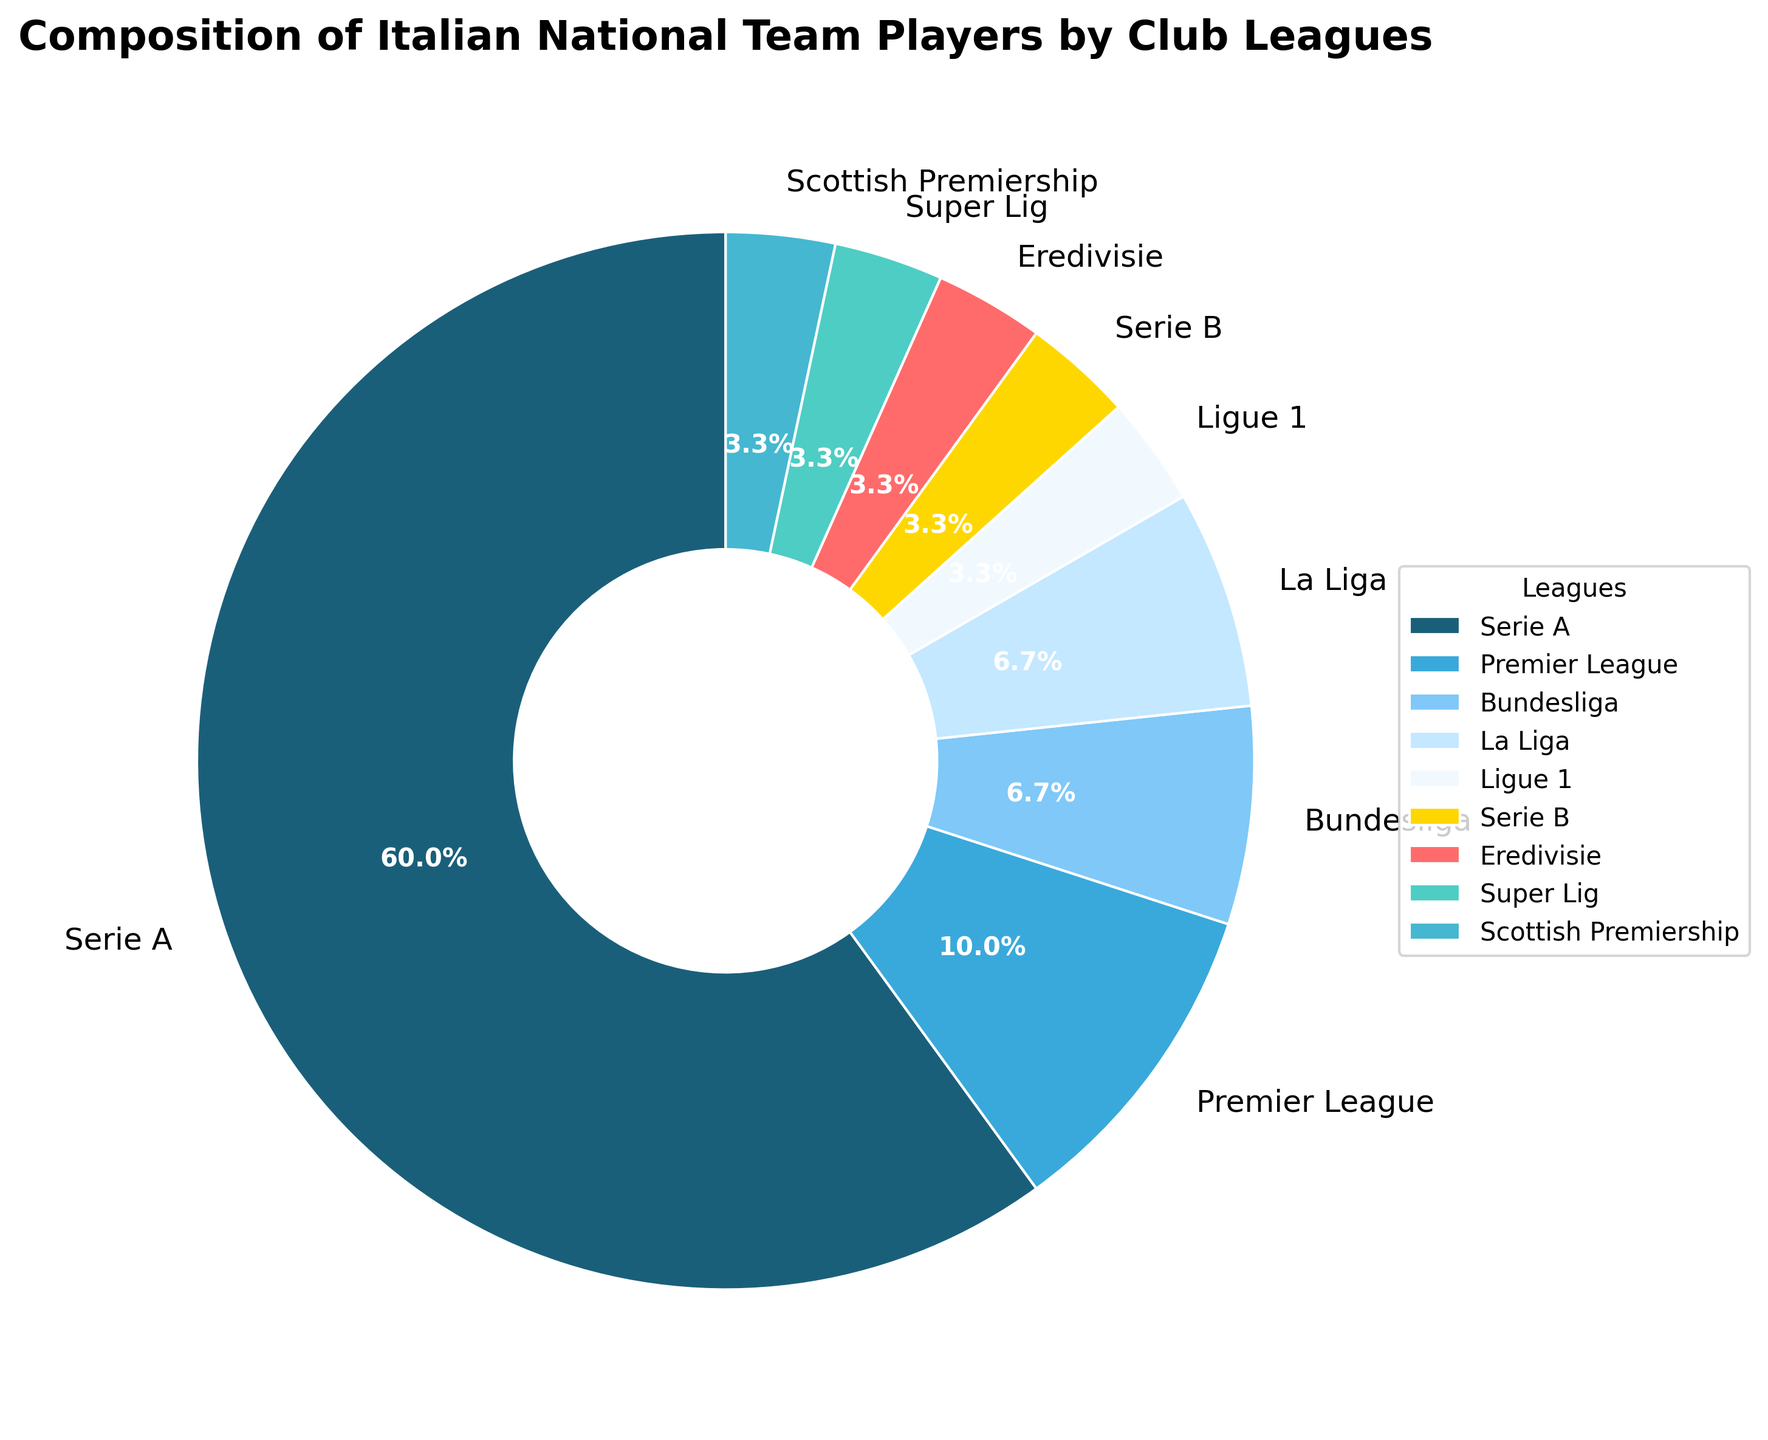What percentage of players are from Serie A and Serie B combined? To find the combined percentage of players from Serie A and Serie B, sum up the players from both leagues first: 18 (Serie A) + 1 (Serie B) = 19. Then, find the percentage by summing the individual percentages from the pie chart: Serie A (18/30*100) = 60%, Serie B (1/30*100) = 3.3%, so combined is 60% + 3.3% = 63.3%.
Answer: 63.3% Which league has the highest number of players, and how many more players does it have compared to the Premier League? Serie A has the highest number of players at 18. The Premier League has 3 players. The difference between them is 18 - 3 = 15.
Answer: 15 What is the color used to represent the Eredivisie in the pie chart? By visually examining the pie chart legend, the Eredivisie is represented by a specific color. The corresponding color may vary but should match one of the unique segment colors, such as yellow, based on the description provided.
Answer: yellow Which league has the second-largest proportion of players in the Italian national team? Compare the proportions of each league in the pie chart. The Premier League, with 3 players, holds the second-largest proportion after Serie A.
Answer: Premier League How many players in total are there from leagues outside of Italy? Sum the number of players in leagues outside of Italy: Premier League (3) + Bundesliga (2) + La Liga (2) + Ligue 1 (1) + Eredivisie (1) + Super Lig (1) + Scottish Premiership (1) = 11.
Answer: 11 